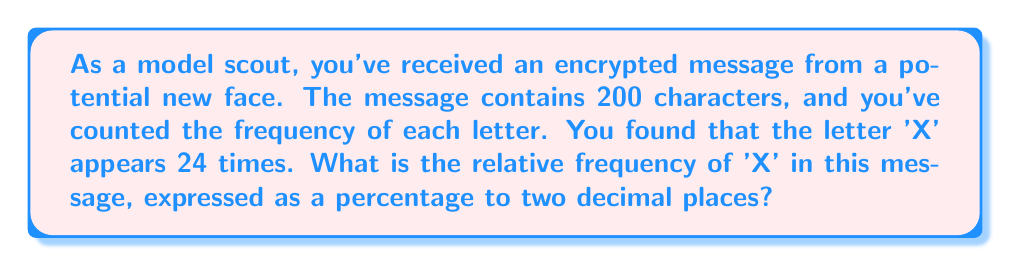Solve this math problem. To solve this problem, we need to follow these steps:

1. Understand the concept of relative frequency:
   Relative frequency is the ratio of the number of occurrences of a particular event to the total number of events, often expressed as a percentage.

2. Identify the given information:
   - Total characters in the message: 200
   - Number of times 'X' appears: 24

3. Calculate the relative frequency:
   $$ \text{Relative Frequency} = \frac{\text{Number of occurrences}}{\text{Total number of events}} $$

   $$ \text{Relative Frequency} = \frac{24}{200} = 0.12 $$

4. Convert to percentage:
   $$ \text{Percentage} = \text{Relative Frequency} \times 100\% $$
   $$ \text{Percentage} = 0.12 \times 100\% = 12\% $$

5. Round to two decimal places:
   The result is already in two decimal places, so no further rounding is needed.

Thus, the relative frequency of 'X' in the encrypted message is 12.00%.
Answer: 12.00% 